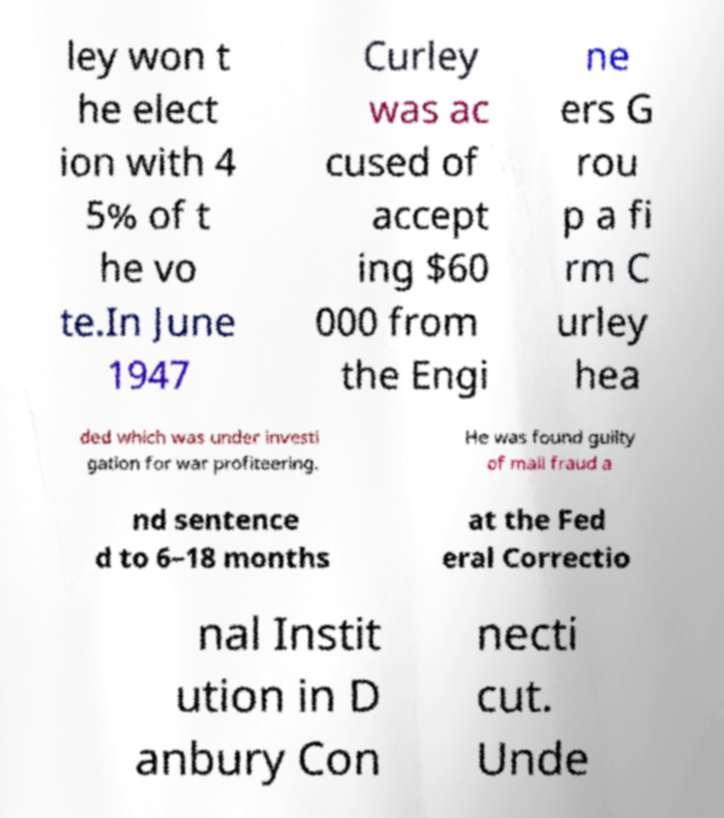Can you accurately transcribe the text from the provided image for me? ley won t he elect ion with 4 5% of t he vo te.In June 1947 Curley was ac cused of accept ing $60 000 from the Engi ne ers G rou p a fi rm C urley hea ded which was under investi gation for war profiteering. He was found guilty of mail fraud a nd sentence d to 6–18 months at the Fed eral Correctio nal Instit ution in D anbury Con necti cut. Unde 